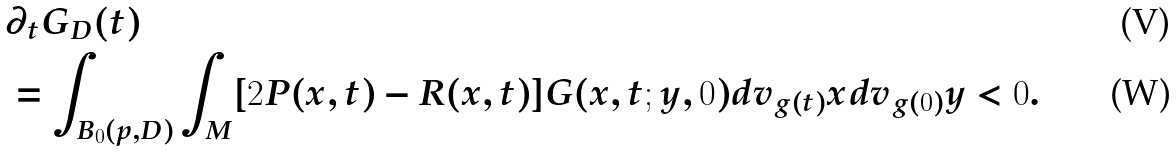<formula> <loc_0><loc_0><loc_500><loc_500>& \partial _ { t } G _ { D } ( t ) \\ & = \int _ { B _ { 0 } ( p , D ) } \int _ { M } [ 2 P ( x , t ) - R ( x , t ) ] G ( x , t ; y , 0 ) d v _ { g ( t ) } x d v _ { g ( 0 ) } y < 0 .</formula> 